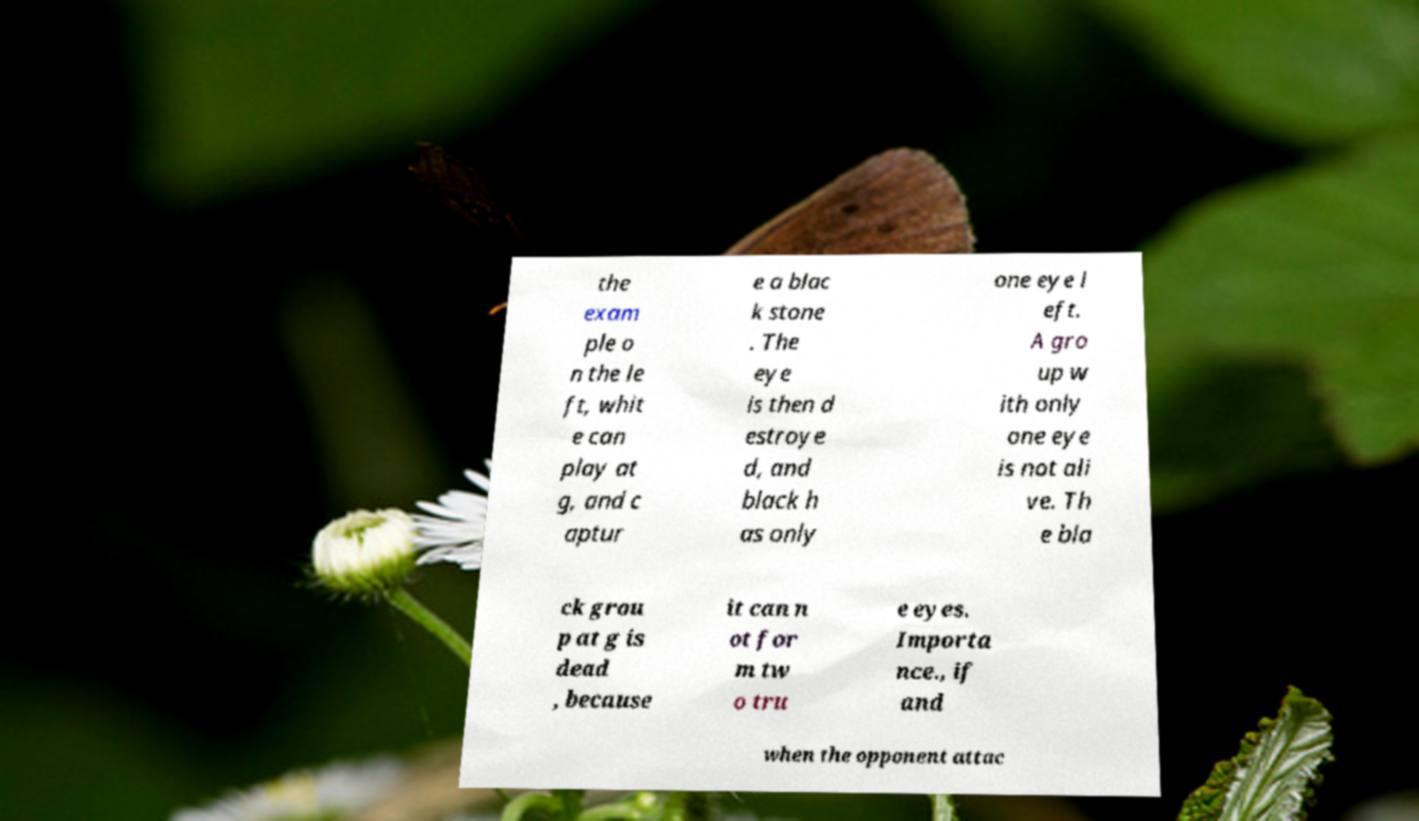Could you assist in decoding the text presented in this image and type it out clearly? the exam ple o n the le ft, whit e can play at g, and c aptur e a blac k stone . The eye is then d estroye d, and black h as only one eye l eft. A gro up w ith only one eye is not ali ve. Th e bla ck grou p at g is dead , because it can n ot for m tw o tru e eyes. Importa nce., if and when the opponent attac 